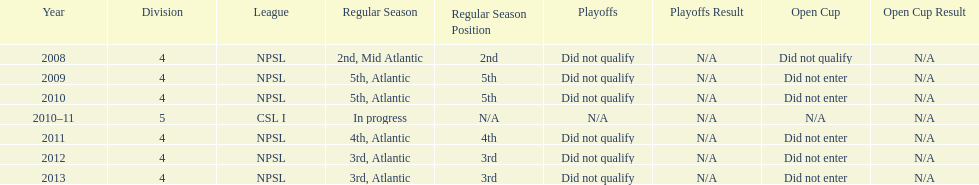How many 3rd place finishes has npsl had? 2. 